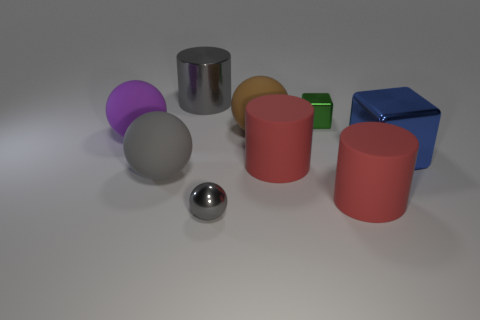There is a rubber ball that is the same color as the big shiny cylinder; what is its size?
Your response must be concise. Large. Is the number of tiny blocks in front of the large blue block less than the number of tiny green objects?
Keep it short and to the point. Yes. There is a thing that is both left of the tiny green metal thing and behind the big brown matte object; what is its color?
Your answer should be very brief. Gray. What number of other objects are the same shape as the small gray object?
Provide a short and direct response. 3. Are there fewer large things that are left of the large brown sphere than big balls that are to the left of the gray shiny cylinder?
Offer a terse response. No. Are the blue object and the tiny thing that is behind the brown object made of the same material?
Give a very brief answer. Yes. Are there any other things that have the same material as the blue object?
Your response must be concise. Yes. Are there more gray cylinders than large rubber cylinders?
Your answer should be compact. No. There is a small gray metal object in front of the cube behind the ball that is behind the purple rubber object; what shape is it?
Ensure brevity in your answer.  Sphere. Do the big cylinder on the left side of the small gray thing and the big ball to the right of the small ball have the same material?
Offer a very short reply. No. 